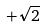<formula> <loc_0><loc_0><loc_500><loc_500>+ \sqrt { 2 }</formula> 